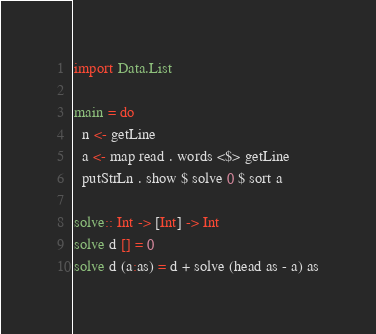<code> <loc_0><loc_0><loc_500><loc_500><_Haskell_>import Data.List

main = do
  n <- getLine
  a <- map read . words <$> getLine
  putStrLn . show $ solve 0 $ sort a

solve:: Int -> [Int] -> Int
solve d [] = 0
solve d (a:as) = d + solve (head as - a) as</code> 